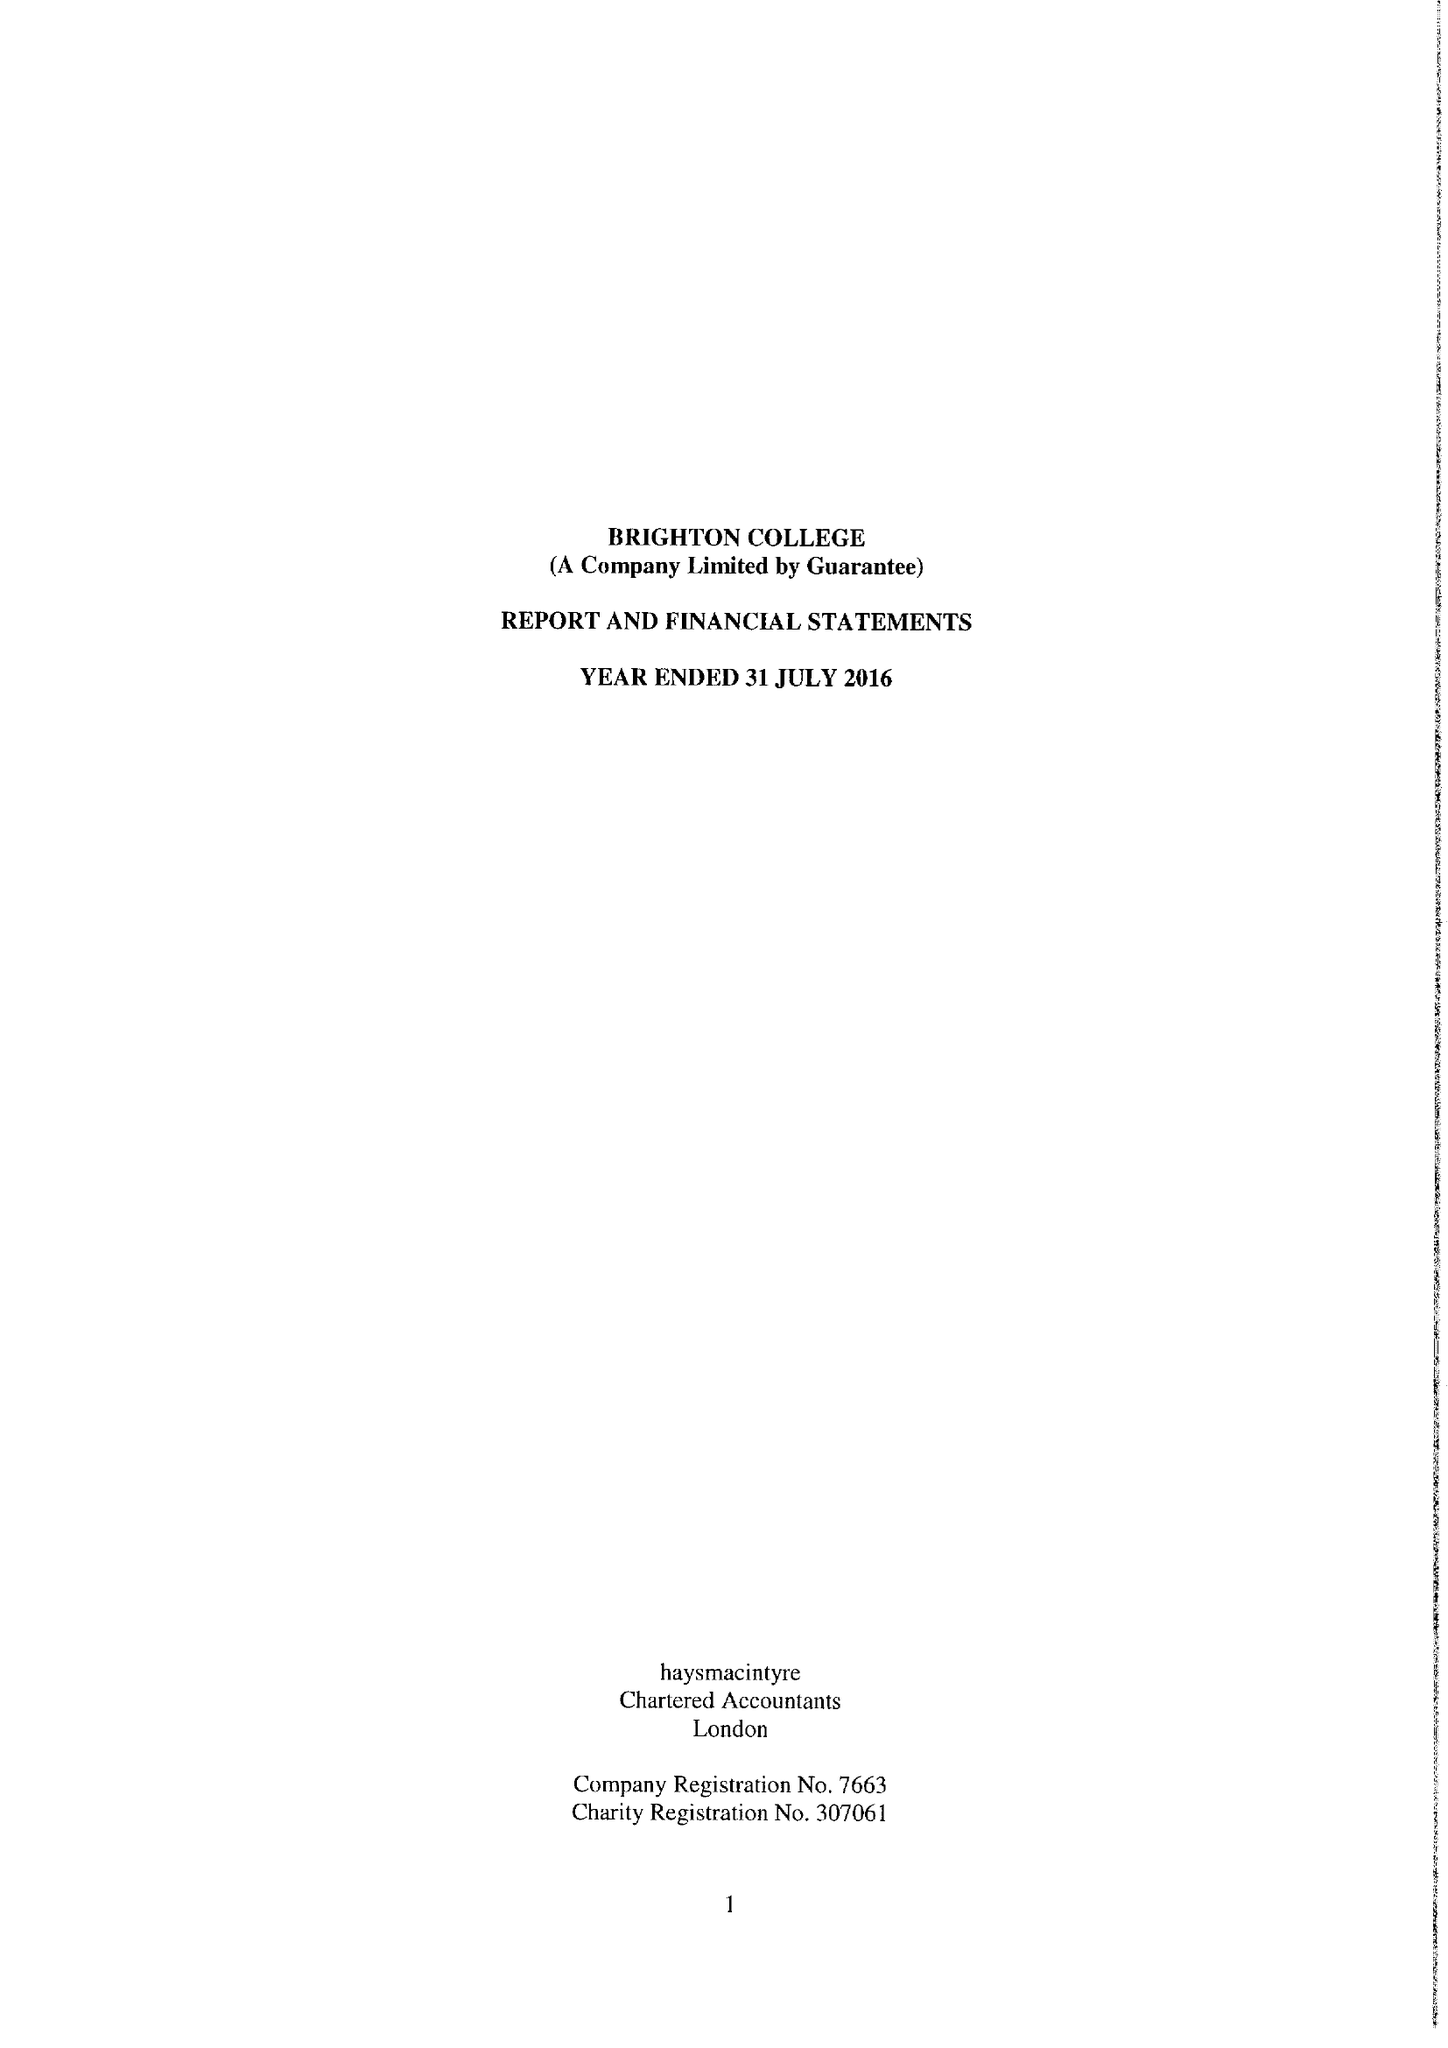What is the value for the address__street_line?
Answer the question using a single word or phrase. EASTERN ROAD 